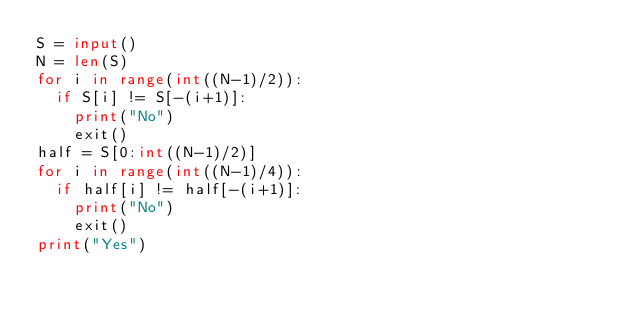Convert code to text. <code><loc_0><loc_0><loc_500><loc_500><_Python_>S = input()
N = len(S)
for i in range(int((N-1)/2)):
  if S[i] != S[-(i+1)]:
    print("No")
    exit()
half = S[0:int((N-1)/2)]
for i in range(int((N-1)/4)):
  if half[i] != half[-(i+1)]:
    print("No")
    exit()
print("Yes")</code> 